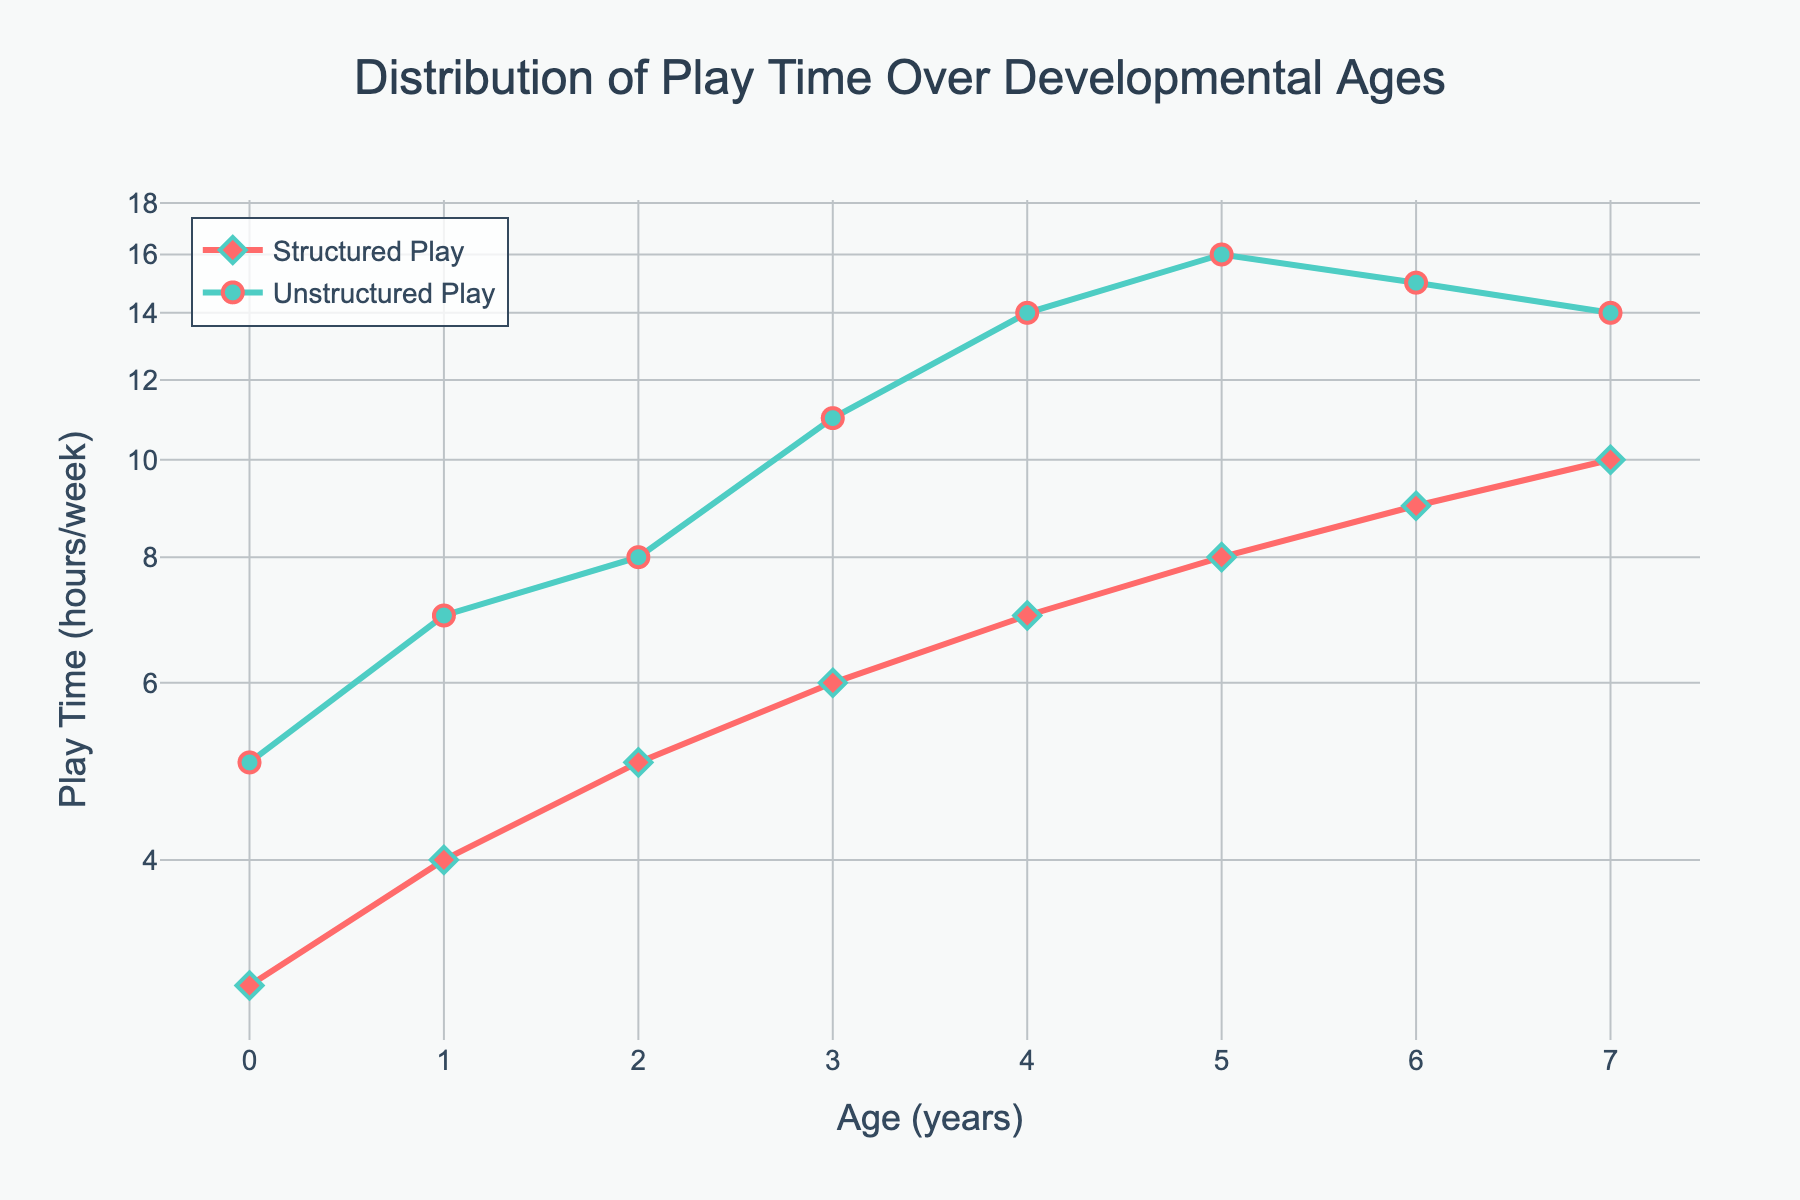What is the title of the plot? The title of the plot is displayed prominently at the top of the figure. It summarizes the overall content and purpose of the plot.
Answer: Distribution of Play Time Over Developmental Ages How many age groups are represented in the plot? The age groups are indicated along the x-axis of the plot, starting from 0 years to 7 years. Counting these ticks will give the total number of age groups.
Answer: 8 What color is used for the line representing Structured Play? To determine this, look at the lines and markers on the plot, focusing on the color used for Structured Play. This can be cross-referenced with the legend.
Answer: Red How many hours per week is spent on Unstructured Play at age 3? Locate the age '3' along the x-axis and find the corresponding value on the y-axis for the line representing Unstructured Play.
Answer: 11 hours/week Between which two ages does Unstructured Play increase the most? To find where Unstructured Play increases the most, observe the plot to see where the steepest slope occurs for the Unstructured Play line.
Answer: Age 3 to Age 4 What is the difference in play time for Structured Play between ages 1 and 5? Find the y-values for Structured Play at ages 1 and 5, and subtract the hours at age 1 from the hours at age 5. Age 1: 4 hours, Age 5: 8 hours. Difference: 8 - 4.
Answer: 4 hours What is the trend in Structured Play as children age from 0 to 7 years? Observe the overall direction of the line representing Structured Play from age 0 to age 7.
Answer: Increasing trend By what factor does the structured play time change from age 0 to 7? Compare the structured play time at age 0 (3 hours) to the play time at age 7 (10 hours) and find the ratio. Factor = 10 / 3.
Answer: Approximately 3.33 At what age do Structured and Unstructured Play times start to converge? Look for the point in the plot where the lines representing Structured and Unstructured Play start to get closer to each other.
Answer: Around age 6 Which type of play, structured or unstructured, shows a decreasing trend after a certain age, and at what age does this occur? Examine both lines for any downward trend after a certain age.
Answer: Unstructured Play, after age 5 